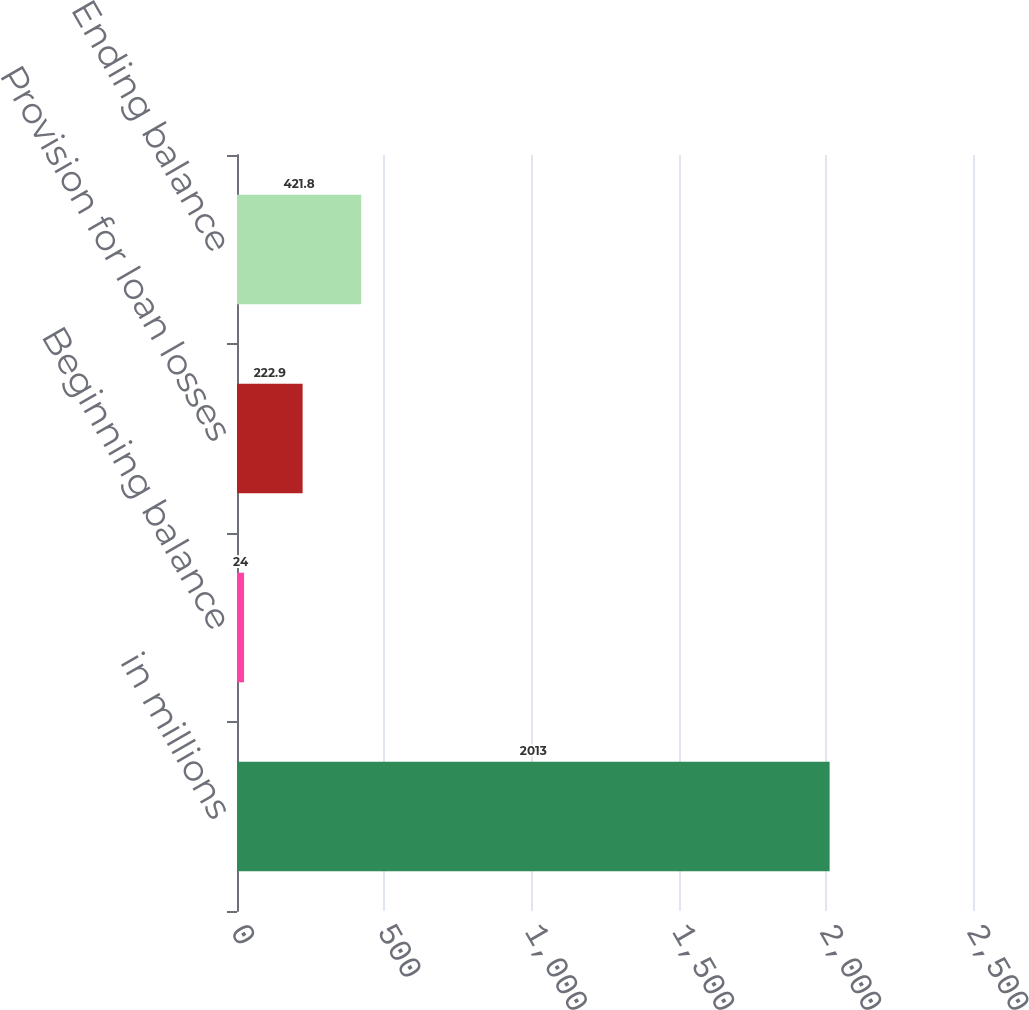<chart> <loc_0><loc_0><loc_500><loc_500><bar_chart><fcel>in millions<fcel>Beginning balance<fcel>Provision for loan losses<fcel>Ending balance<nl><fcel>2013<fcel>24<fcel>222.9<fcel>421.8<nl></chart> 